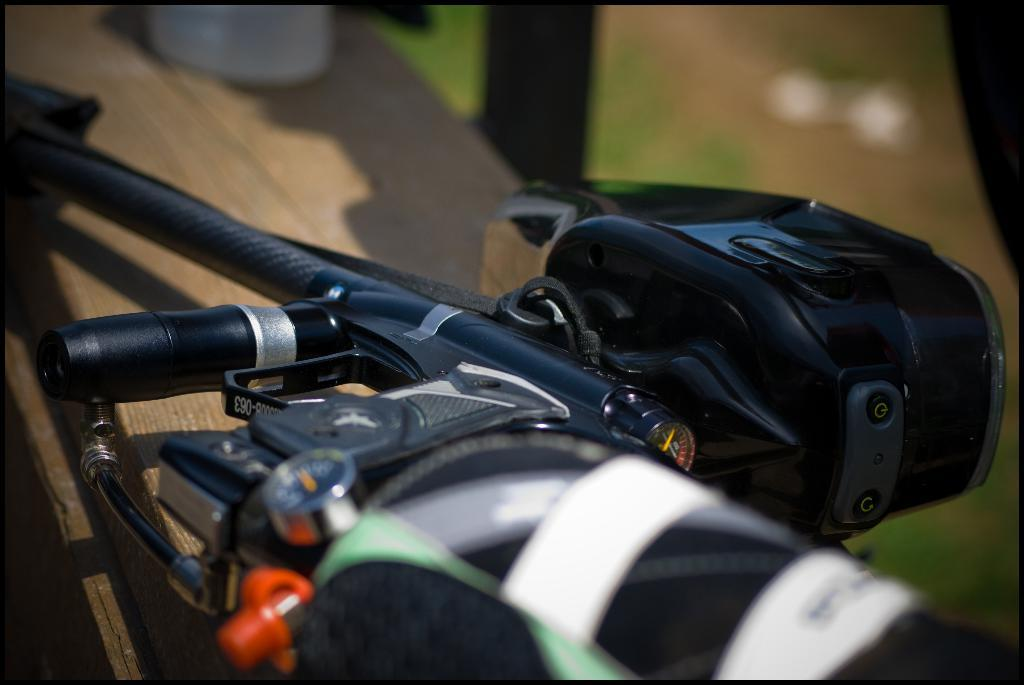What can be seen in the image? There is a front part of a bicycle in the image. Can you describe the bicycle part in more detail? Unfortunately, the provided facts do not offer more details about the front part of the bicycle. Is there anything else visible in the image besides the bicycle part? The facts do not mention any other objects or elements in the image. How many fish are swimming around the bicycle in the image? There are no fish present in the image; it only features the front part of a bicycle. 